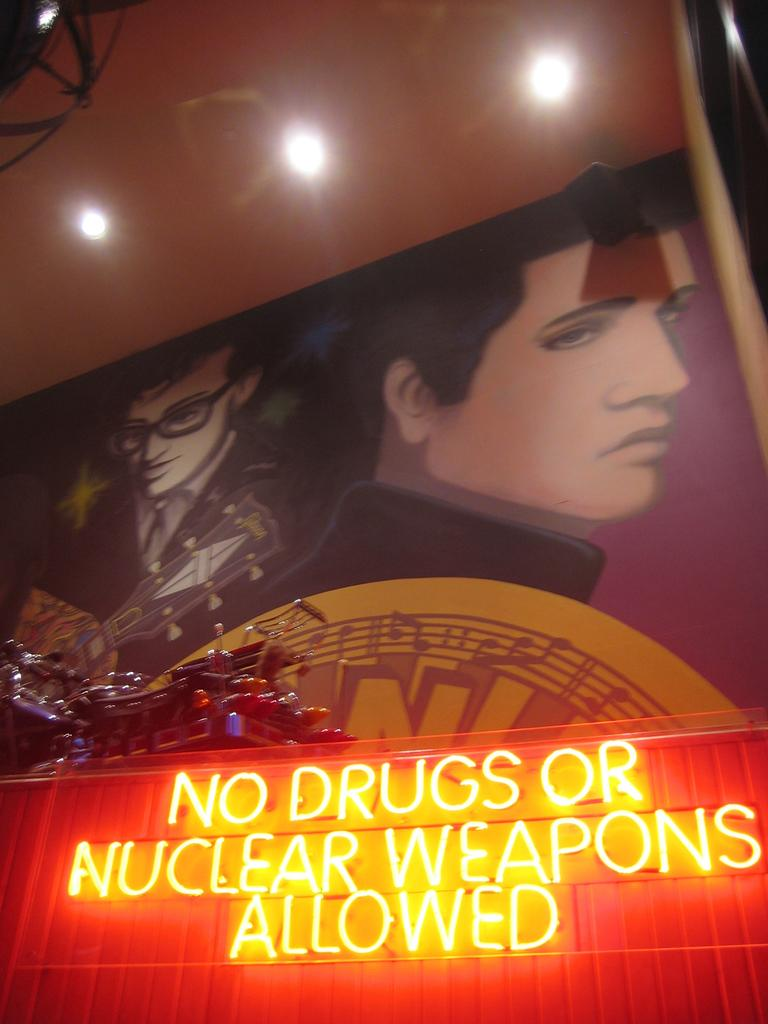<image>
Give a short and clear explanation of the subsequent image. LED light on the wall that says "No Drugs or Nuclear Weapons Allowed". 